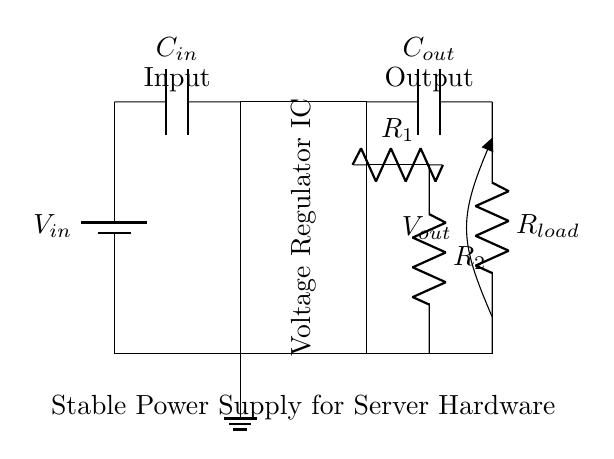What is the input voltage of this circuit? The input voltage, represented as V_in in the circuit diagram, is the voltage supplied from the battery.
Answer: V_in What is the purpose of capacitor C_in? Capacitor C_in is used as an input filter capacitor to smooth the input voltage and reduce any noise that could affect the regulator's performance.
Answer: Filtering What does the voltage regulator IC do? The voltage regulator IC maintains a stable output voltage, even with variations in input voltage or load conditions, to protect sensitive components.
Answer: Voltage regulation What are R1 and R2 used for? R1 and R2 form a voltage divider that provides feedback to the voltage regulator IC, helping it adjust and maintain the correct output voltage.
Answer: Feedback What is the output voltage of this circuit? The output voltage is the regulated voltage provided to the load, indicated by V_out in the diagram.
Answer: V_out How many capacitors are present in the circuit? The circuit contains two capacitors, C_in and C_out, which are both essential for filtering and stability.
Answer: Two What is the load connected to this circuit? The load is represented by resistor R_load, which is the component that consumes the output power from the voltage regulator.
Answer: R_load 